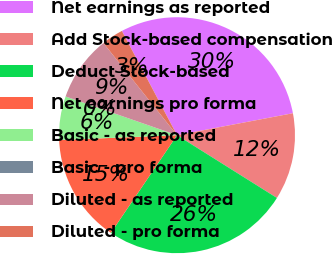Convert chart. <chart><loc_0><loc_0><loc_500><loc_500><pie_chart><fcel>Net earnings as reported<fcel>Add Stock-based compensation<fcel>Deduct Stock-based<fcel>Net earnings pro forma<fcel>Basic - as reported<fcel>Basic - pro forma<fcel>Diluted - as reported<fcel>Diluted - pro forma<nl><fcel>29.76%<fcel>11.91%<fcel>25.55%<fcel>14.88%<fcel>5.96%<fcel>0.02%<fcel>8.94%<fcel>2.99%<nl></chart> 